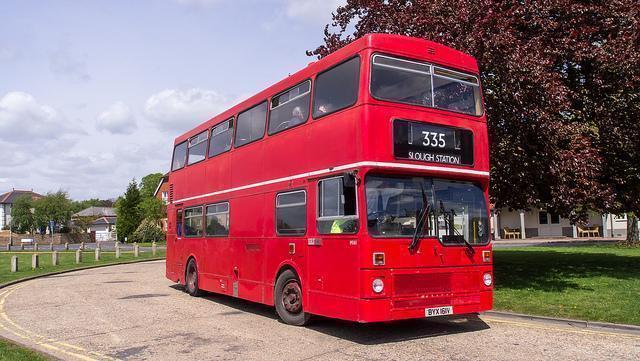One can board a train in which region after they disembark from this bus?
Choose the right answer from the provided options to respond to the question.
Options: Northern, london midland, scottish, western. Western. 